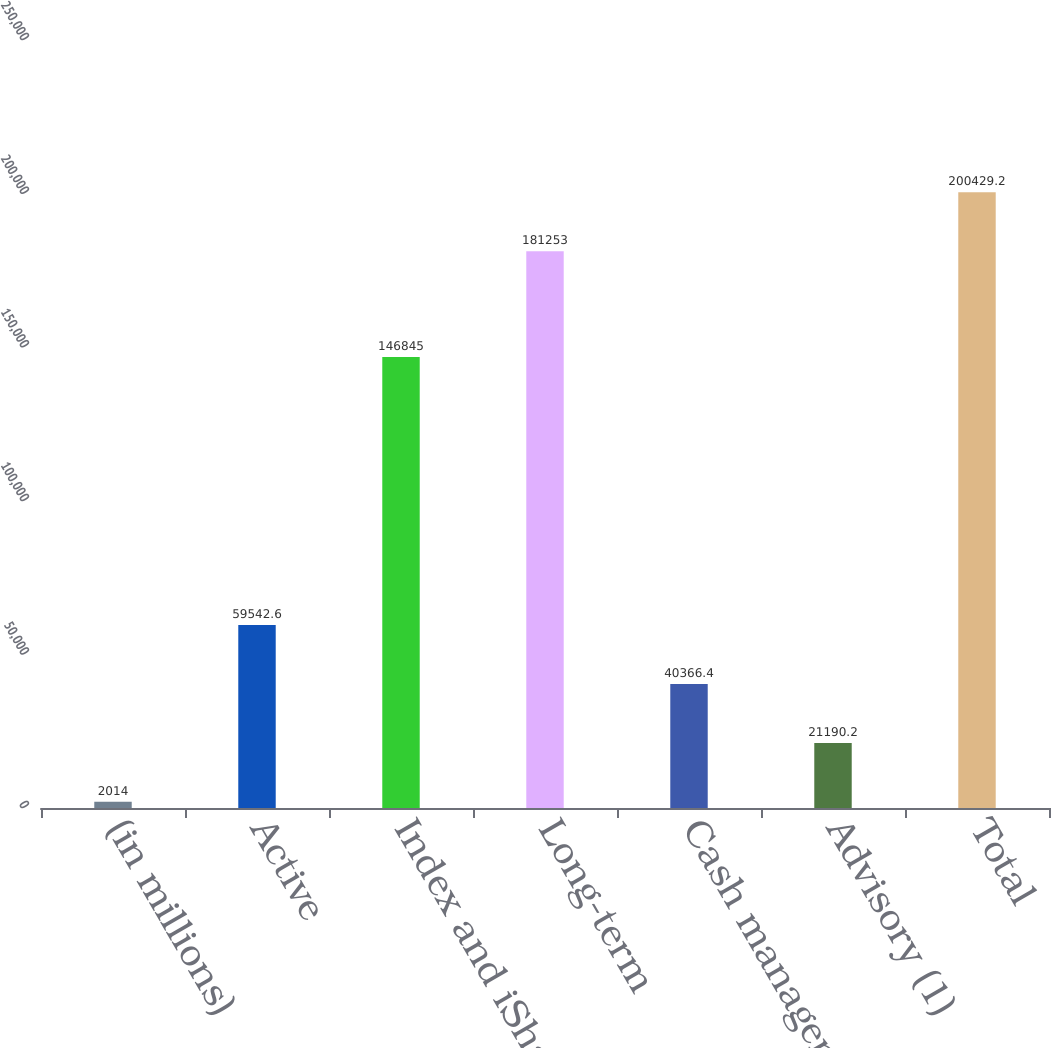Convert chart. <chart><loc_0><loc_0><loc_500><loc_500><bar_chart><fcel>(in millions)<fcel>Active<fcel>Index and iShares<fcel>Long-term<fcel>Cash management<fcel>Advisory (1)<fcel>Total<nl><fcel>2014<fcel>59542.6<fcel>146845<fcel>181253<fcel>40366.4<fcel>21190.2<fcel>200429<nl></chart> 